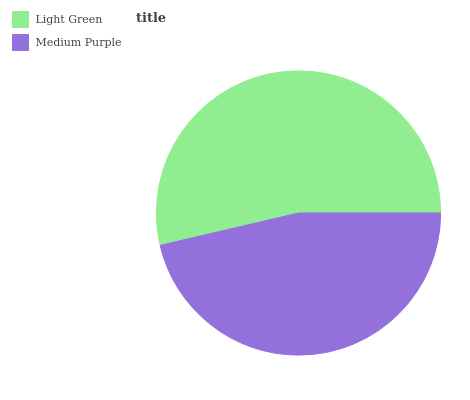Is Medium Purple the minimum?
Answer yes or no. Yes. Is Light Green the maximum?
Answer yes or no. Yes. Is Medium Purple the maximum?
Answer yes or no. No. Is Light Green greater than Medium Purple?
Answer yes or no. Yes. Is Medium Purple less than Light Green?
Answer yes or no. Yes. Is Medium Purple greater than Light Green?
Answer yes or no. No. Is Light Green less than Medium Purple?
Answer yes or no. No. Is Light Green the high median?
Answer yes or no. Yes. Is Medium Purple the low median?
Answer yes or no. Yes. Is Medium Purple the high median?
Answer yes or no. No. Is Light Green the low median?
Answer yes or no. No. 